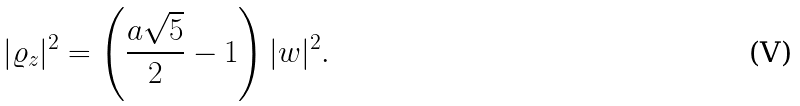<formula> <loc_0><loc_0><loc_500><loc_500>| \varrho _ { z } | ^ { 2 } = \left ( \frac { a \sqrt { 5 } } { 2 } - 1 \right ) | w | ^ { 2 } .</formula> 